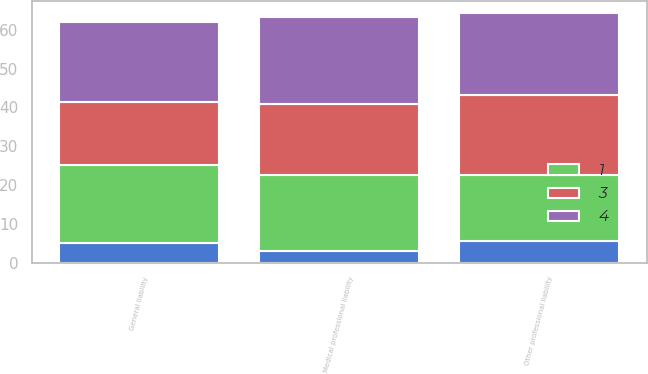Convert chart to OTSL. <chart><loc_0><loc_0><loc_500><loc_500><stacked_bar_chart><ecel><fcel>Medical professional liability<fcel>Other professional liability<fcel>General liability<nl><fcel>nan<fcel>3.1<fcel>5.7<fcel>5<nl><fcel>3<fcel>18.2<fcel>20.6<fcel>16.3<nl><fcel>4<fcel>22.3<fcel>21<fcel>20.5<nl><fcel>1<fcel>19.6<fcel>17<fcel>20.1<nl></chart> 